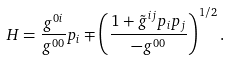<formula> <loc_0><loc_0><loc_500><loc_500>H = \frac { g ^ { 0 i } } { g ^ { 0 0 } } p _ { i } \mp \left ( \frac { 1 + \tilde { g } ^ { i j } p _ { i } p _ { j } } { - g ^ { 0 0 } } \right ) ^ { 1 / 2 } .</formula> 